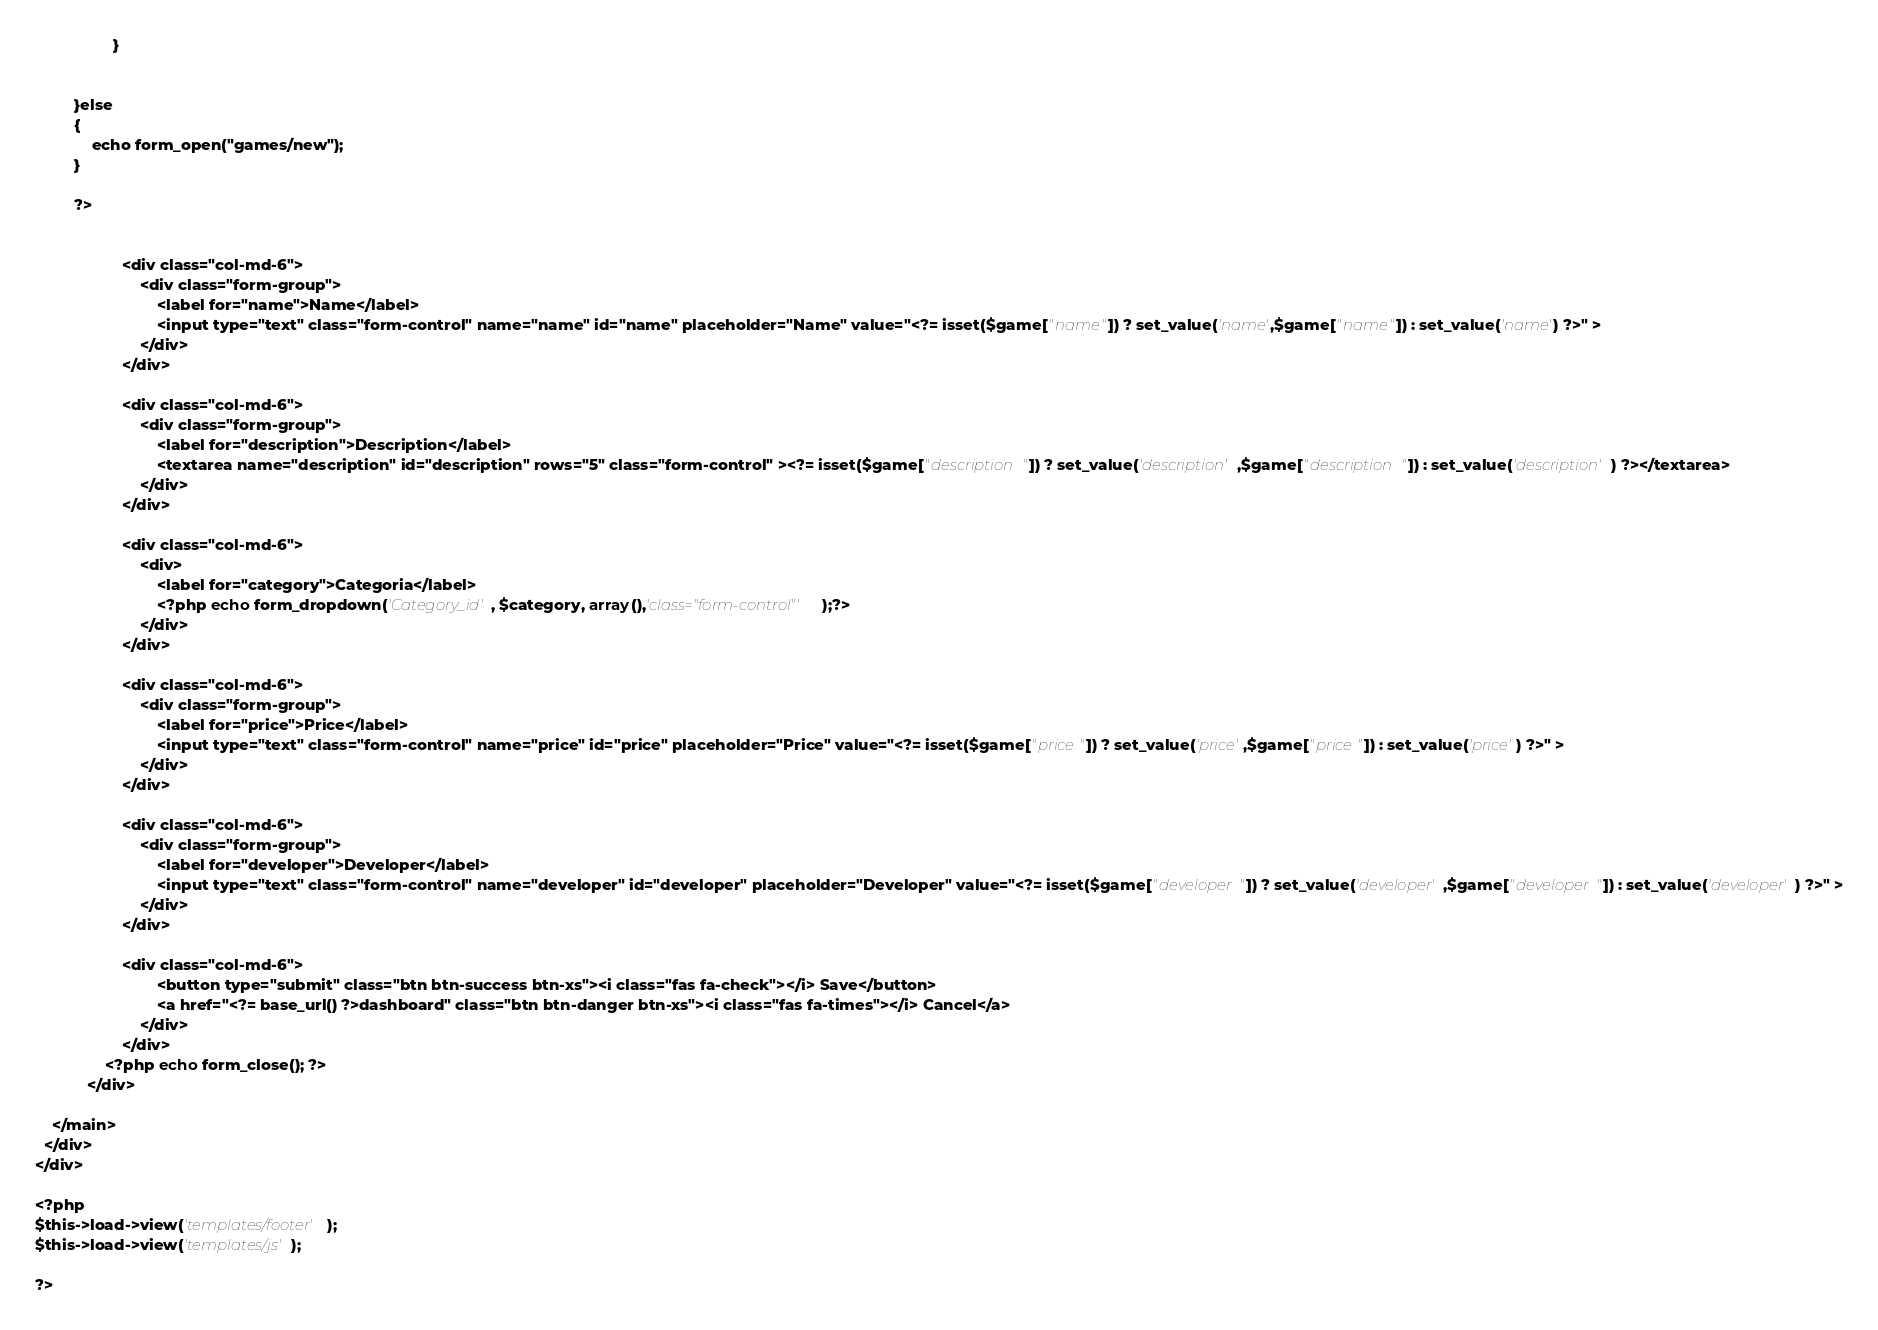Convert code to text. <code><loc_0><loc_0><loc_500><loc_500><_PHP_>				  }		
		

		 }else
		 {
			 echo form_open("games/new");
		 }

		 ?>	
		  

					<div class="col-md-6">
						<div class="form-group">
							<label for="name">Name</label>
							<input type="text" class="form-control" name="name" id="name" placeholder="Name" value="<?= isset($game["name"]) ? set_value('name',$game["name"]) : set_value('name') ?>" >
						</div>
					</div>

					<div class="col-md-6">
						<div class="form-group">
							<label for="description">Description</label>
							<textarea name="description" id="description" rows="5" class="form-control" ><?= isset($game["description"]) ? set_value('description',$game["description"]) : set_value('description') ?></textarea>
						</div>
					</div>

					<div class="col-md-6">
						<div>							
							<label for="category">Categoria</label>
   							<?php echo form_dropdown('Category_id', $category, array(),'class="form-control"' );?>
						</div>
					</div>

					<div class="col-md-6">
						<div class="form-group">
							<label for="price">Price</label>
							<input type="text" class="form-control" name="price" id="price" placeholder="Price" value="<?= isset($game["price"]) ? set_value('price',$game["price"]) : set_value('price') ?>" >
						</div>
					</div>

					<div class="col-md-6">
						<div class="form-group">
							<label for="developer">Developer</label>
							<input type="text" class="form-control" name="developer" id="developer" placeholder="Developer" value="<?= isset($game["developer"]) ? set_value('developer',$game["developer"]) : set_value('developer') ?>" >
						</div>
					</div>

					<div class="col-md-6">
							<button type="submit" class="btn btn-success btn-xs"><i class="fas fa-check"></i> Save</button>
							<a href="<?= base_url() ?>dashboard" class="btn btn-danger btn-xs"><i class="fas fa-times"></i> Cancel</a>
						</div>
					</div>
				<?php echo form_close(); ?>
			</div>

    </main>
  </div>
</div>

<?php
$this->load->view('templates/footer');
$this->load->view('templates/js');

?>
</code> 